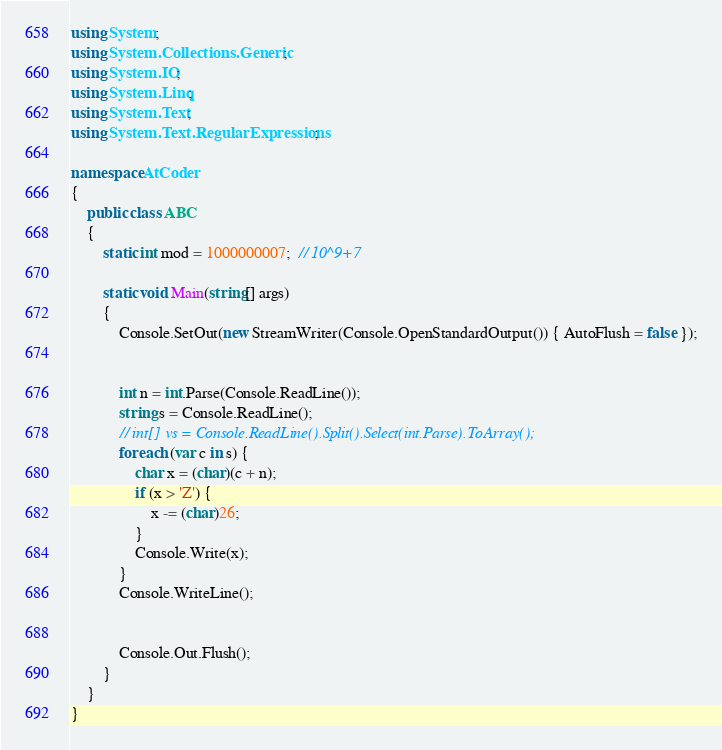Convert code to text. <code><loc_0><loc_0><loc_500><loc_500><_C#_>using System;
using System.Collections.Generic;
using System.IO;
using System.Linq;
using System.Text;
using System.Text.RegularExpressions;

namespace AtCoder
{
	public class ABC
	{
		static int mod = 1000000007;  // 10^9+7

		static void Main(string[] args)
		{
			Console.SetOut(new StreamWriter(Console.OpenStandardOutput()) { AutoFlush = false });


			int n = int.Parse(Console.ReadLine());
			string s = Console.ReadLine();
			// int[] vs = Console.ReadLine().Split().Select(int.Parse).ToArray();
			foreach (var c in s) {
				char x = (char)(c + n);
				if (x > 'Z') {
					x -= (char)26;
				}
				Console.Write(x);
			}
			Console.WriteLine();


			Console.Out.Flush();
		}
	}
}
</code> 